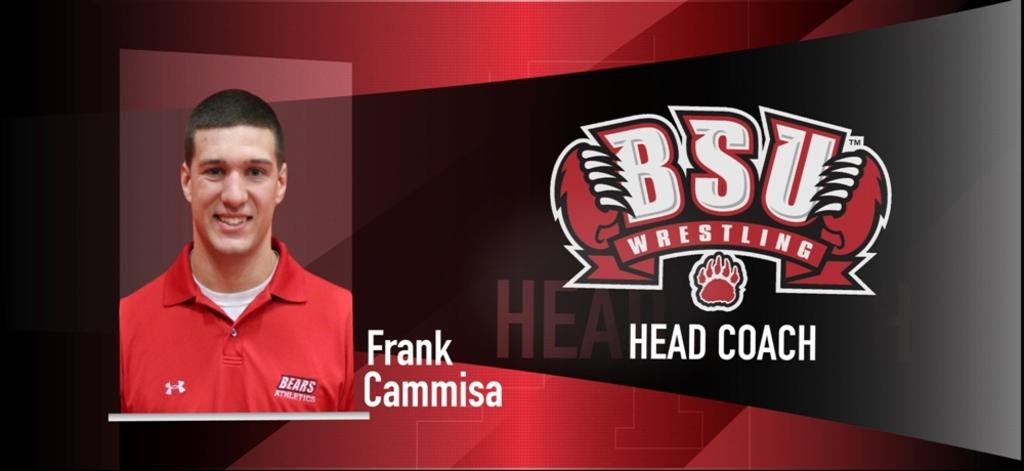<image>
Offer a succinct explanation of the picture presented. A picture of Frank Cammisa is next to a BSU Wrestling Logo 